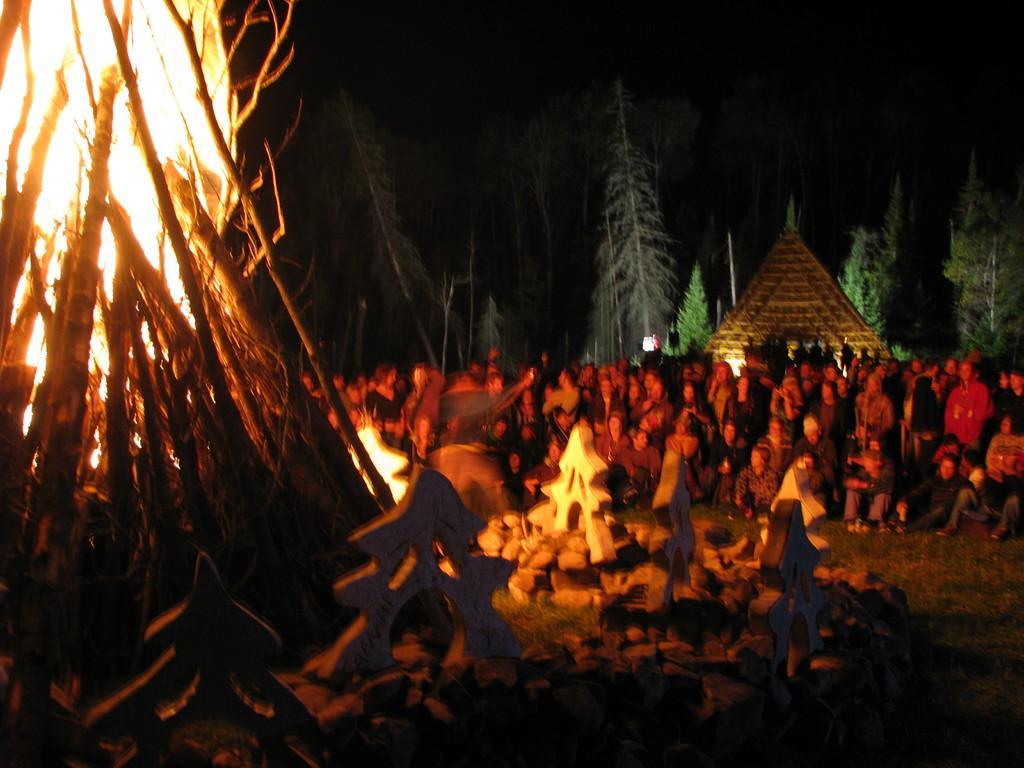Describe this image in one or two sentences. In this picture there are group of people. On the left side of the image there is a campfire and there are stones. At the back there is a building and there are trees. At the top there is sky. At the bottom there is grass. 